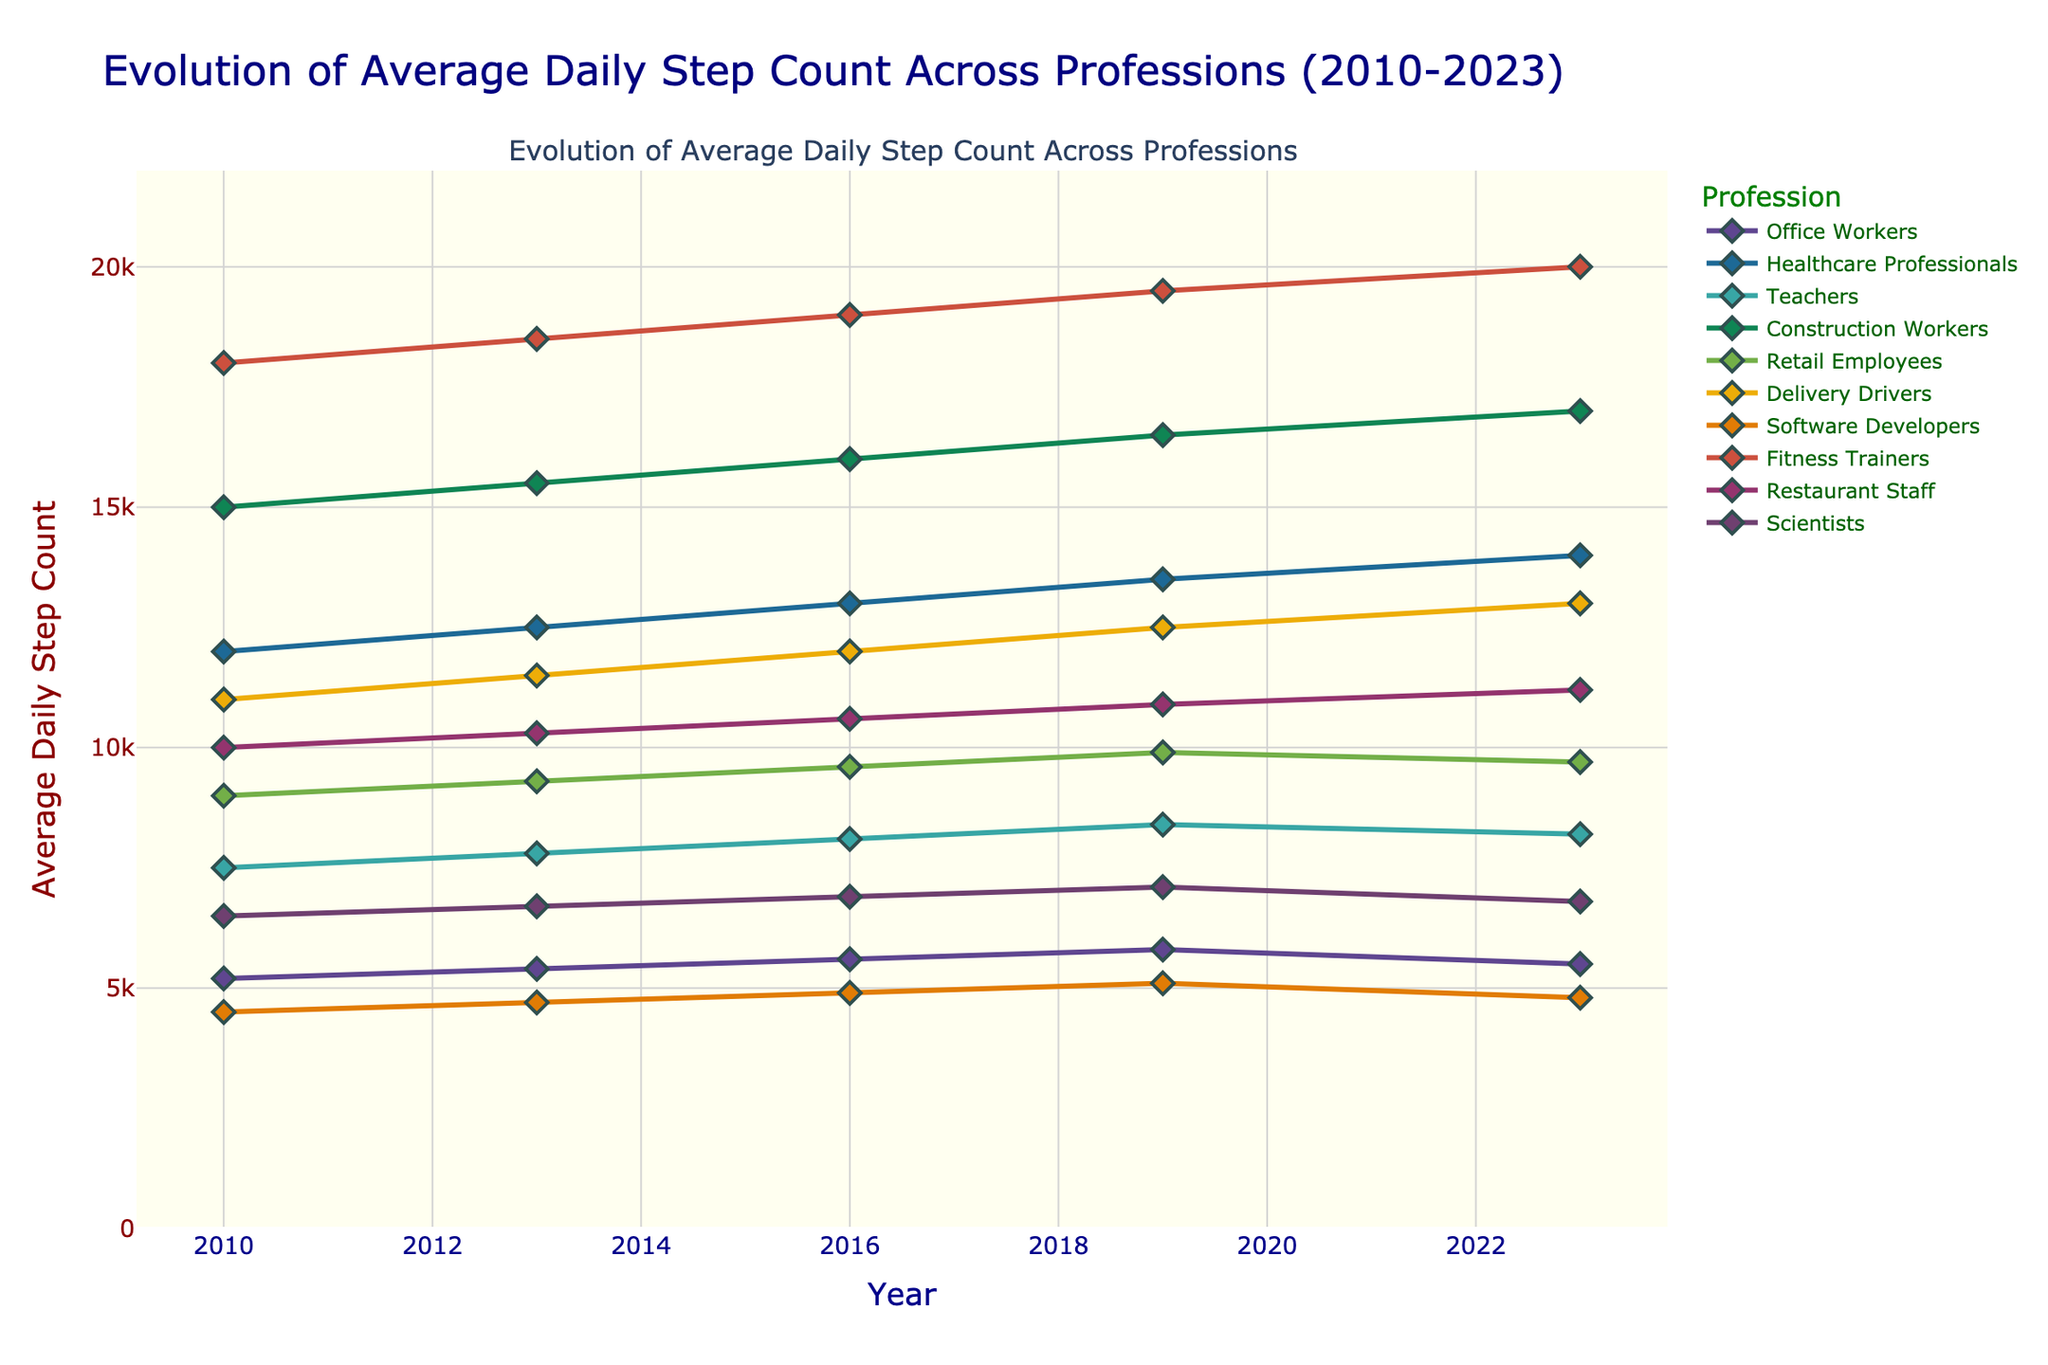Which profession had the highest average daily step count in 2023? Find the line with the highest y-value at the 2023 mark, which is the line representing Fitness Trainers, with 20,000 steps.
Answer: Fitness Trainers How has the average daily step count for Office Workers changed from 2010 to 2023? Observe the y-values of the line representing Office Workers in 2010 and 2023, which are 5200 and 5500 steps respectively. The step count increased by 300.
Answer: Increased by 300 Which profession showed the largest increase in average daily step count from 2010 to 2023? Calculate the differences between 2023 and 2010 step counts for all professions. Fitness Trainers increased from 18000 to 20000, a difference of 2000 steps, which is the largest.
Answer: Fitness Trainers Between Healthcare Professionals and Delivery Drivers, who had a higher average step count in 2016? Compare the y-values for Healthcare Professionals and Delivery Drivers at the 2016 mark, which are 13000 and 12000 steps respectively. Healthcare Professionals have a higher step count.
Answer: Healthcare Professionals What is the range of average daily step counts for scientists from 2010 to 2023? Identify the highest (7100 in 2019) and lowest (6500 in 2010) y-values for Scientists, then subtract the lowest from the highest (7100 - 6500 = 600).
Answer: 600 Which profession had the lowest average daily step count in 2019? Find the line with the lowest y-value at the 2019 mark, which is the line representing Software Developers, with 5100 steps.
Answer: Software Developers Has the average daily step count for Teachers increased or decreased from 2019 to 2023? Compare the y-values of Teachers in 2019 (8400 steps) and 2023 (8200 steps). The step count decreased by 200.
Answer: Decreased What is the combined average daily step count for Restaurant Staff and Office Workers in 2023? Sum the y-values for Restaurant Staff (11200 steps) and Office Workers (5500 steps) in 2023. 11200 + 5500 = 16700 steps.
Answer: 16700 Compare the trends for Healthcare Professionals and Software Developers from 2010 to 2023. Who showed a more consistent increase? Healthcare Professionals show a steady increase from 12000 to 14000, while Software Developers rise to 5100 in 2019 then fall to 4800 in 2023. Healthcare Professionals had a more consistent increase.
Answer: Healthcare Professionals How did the average step count for Retail Employees change during the period from 2010 to 2019 compared to 2019 to 2023? Retail Employees had step counts of 9000 in 2010, 9900 in 2019, and 9700 in 2023. The change from 2010 to 2019 is an increase of 900 (9900 - 9000), and from 2019 to 2023 is a decrease of 200 (9700 - 9900).
Answer: Increased by 900, then decreased by 200 